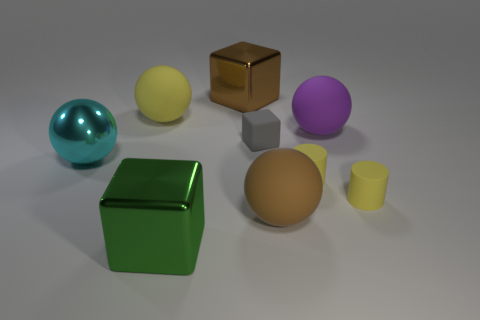Does the small cube have the same material as the brown thing in front of the large yellow sphere?
Your response must be concise. Yes. Is there a big object on the right side of the large cube that is in front of the brown metal cube that is behind the big purple matte object?
Provide a short and direct response. Yes. There is another large block that is the same material as the green block; what color is it?
Keep it short and to the point. Brown. What size is the rubber ball that is behind the brown matte ball and in front of the large yellow sphere?
Your answer should be compact. Large. Are there fewer yellow matte spheres to the left of the metallic sphere than large metal objects that are in front of the large purple rubber thing?
Make the answer very short. Yes. Is the material of the large brown thing that is in front of the gray block the same as the brown thing that is behind the small cube?
Offer a very short reply. No. There is a metallic thing that is both on the left side of the brown shiny cube and on the right side of the big metal ball; what is its shape?
Provide a succinct answer. Cube. The big green block left of the rubber object that is on the right side of the large purple matte object is made of what material?
Offer a terse response. Metal. Are there more tiny metal objects than big yellow spheres?
Provide a succinct answer. No. Do the tiny block and the metallic sphere have the same color?
Your answer should be compact. No. 